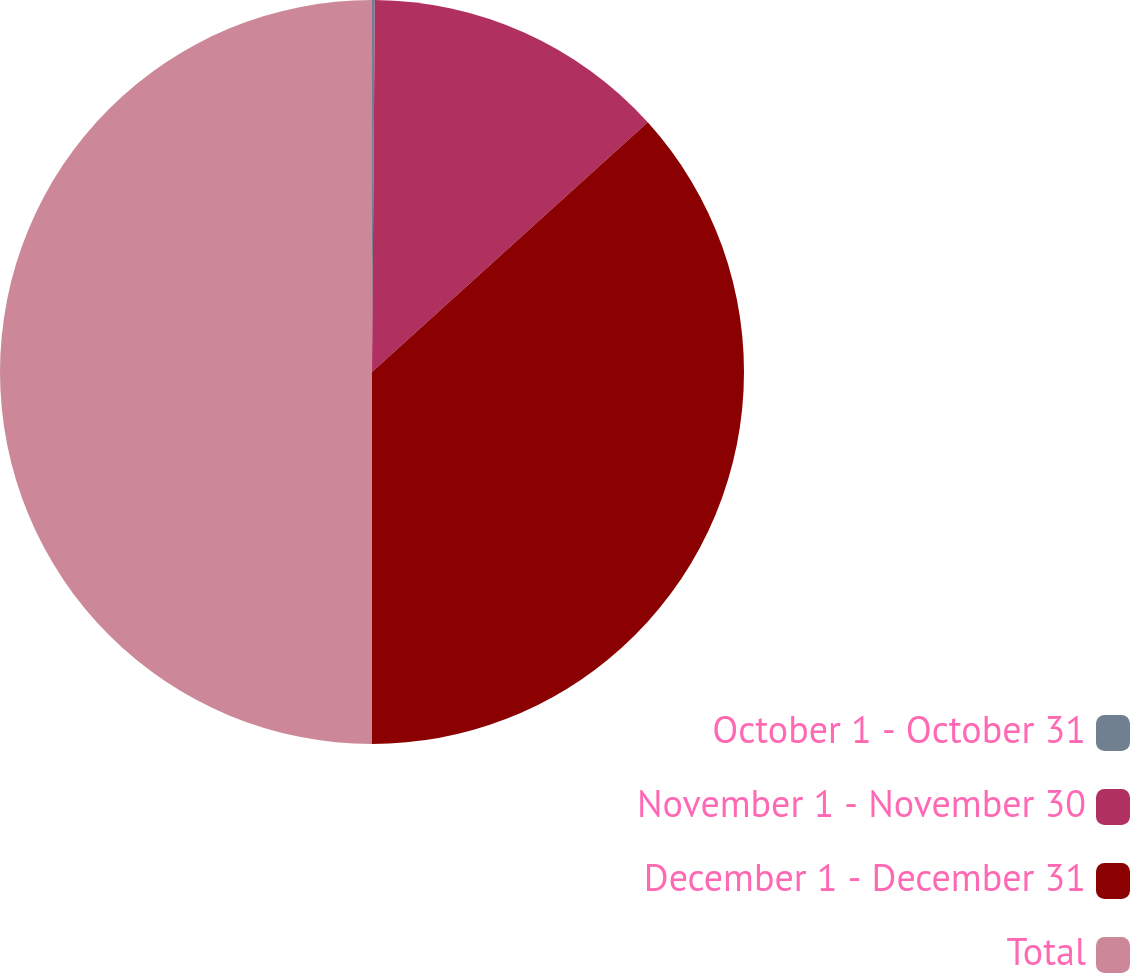<chart> <loc_0><loc_0><loc_500><loc_500><pie_chart><fcel>October 1 - October 31<fcel>November 1 - November 30<fcel>December 1 - December 31<fcel>Total<nl><fcel>0.12%<fcel>13.17%<fcel>36.71%<fcel>50.0%<nl></chart> 